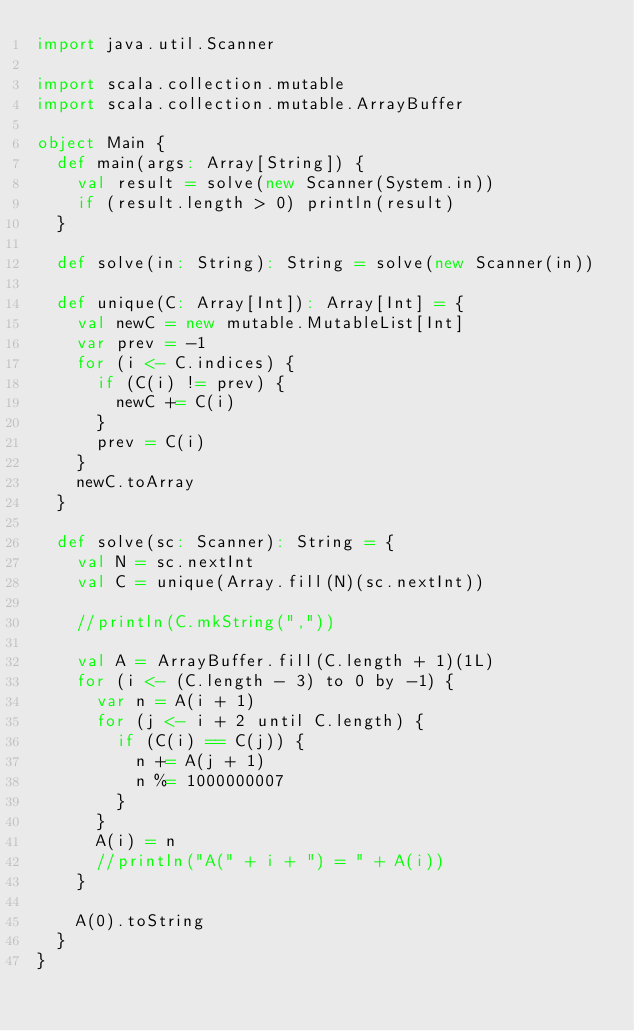<code> <loc_0><loc_0><loc_500><loc_500><_Scala_>import java.util.Scanner

import scala.collection.mutable
import scala.collection.mutable.ArrayBuffer

object Main {
  def main(args: Array[String]) {
    val result = solve(new Scanner(System.in))
    if (result.length > 0) println(result)
  }

  def solve(in: String): String = solve(new Scanner(in))

  def unique(C: Array[Int]): Array[Int] = {
    val newC = new mutable.MutableList[Int]
    var prev = -1
    for (i <- C.indices) {
      if (C(i) != prev) {
        newC += C(i)
      }
      prev = C(i)
    }
    newC.toArray
  }

  def solve(sc: Scanner): String = {
    val N = sc.nextInt
    val C = unique(Array.fill(N)(sc.nextInt))

    //println(C.mkString(","))

    val A = ArrayBuffer.fill(C.length + 1)(1L)
    for (i <- (C.length - 3) to 0 by -1) {
      var n = A(i + 1)
      for (j <- i + 2 until C.length) {
        if (C(i) == C(j)) {
          n += A(j + 1)
          n %= 1000000007
        }
      }
      A(i) = n
      //println("A(" + i + ") = " + A(i))
    }

    A(0).toString
  }
}
</code> 